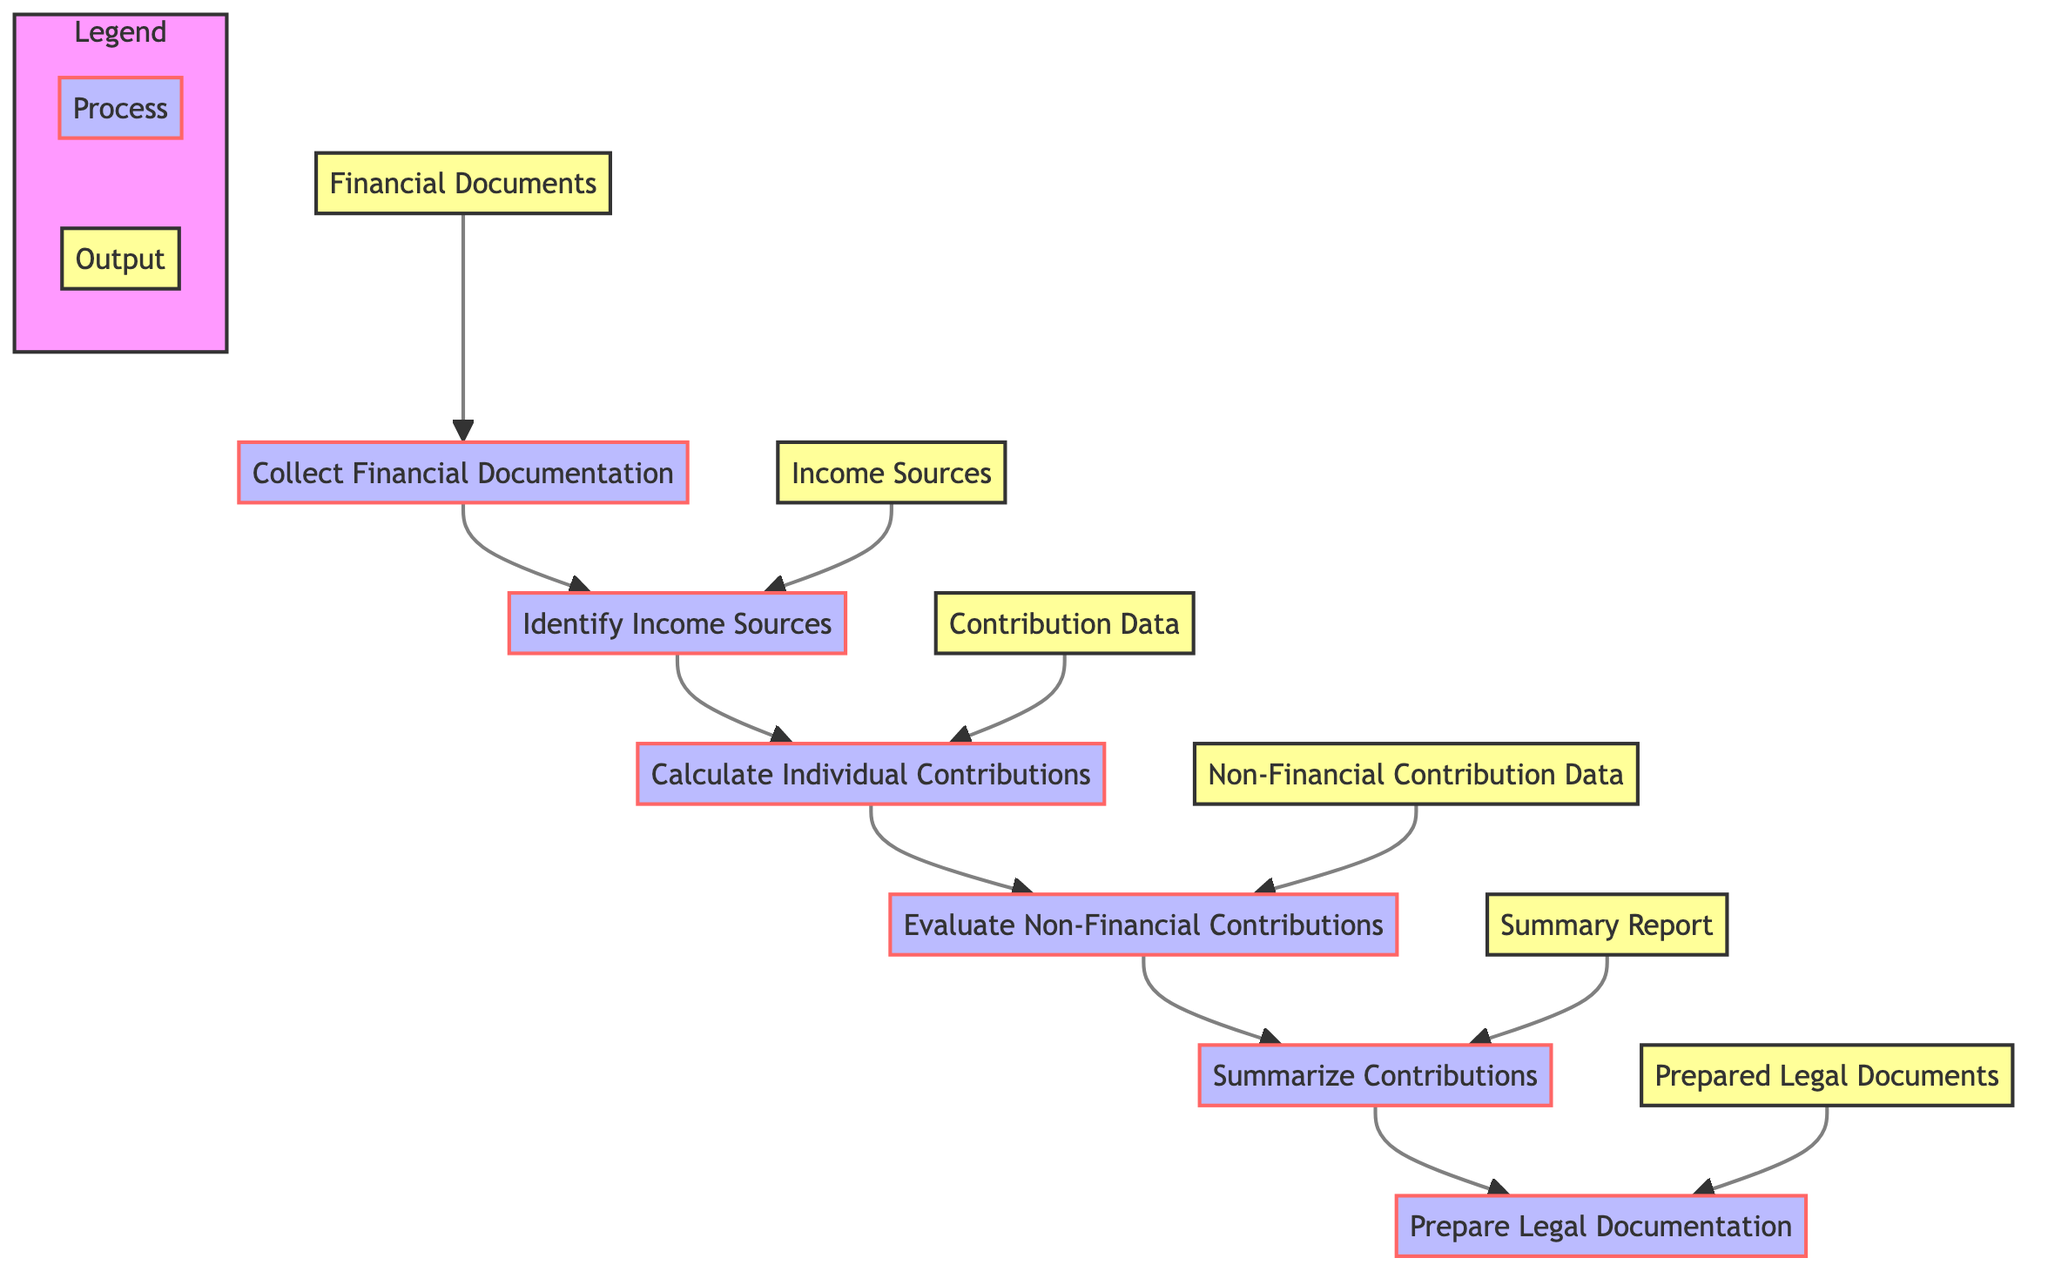What is the first step in the flowchart? The first step in the flowchart is "Collect Financial Documentation," which indicates that gathering relevant financial documents is the starting point of the process.
Answer: Collect Financial Documentation Which step follows "Identify Income Sources"? "Calculate Individual Contributions" directly follows "Identify Income Sources" in the flowchart, indicating that after identifying income sources, the next action is to calculate the contributions.
Answer: Calculate Individual Contributions How many total processes are displayed in the flowchart? The flowchart consists of six processes, which include "Collect Financial Documentation," "Identify Income Sources," "Calculate Individual Contributions," "Evaluate Non-Financial Contributions," "Summarize Contributions," and "Prepare Legal Documentation."
Answer: Six What is the output of the "Summarize Contributions" step? The output of the "Summarize Contributions" step is a "Summary Report," which indicates the result of summarizing both financial and non-financial contributions.
Answer: Summary Report Which node provides input for the "Prepare Legal Documentation" step? The "Summary Report" node provides the necessary input for the "Prepare Legal Documentation" step, showing that the summary needs to be prepared before creating legal documentation.
Answer: Summary Report What determines the flow from "Evaluate Non-Financial Contributions" to "Summarize Contributions"? The flow is determined by the completion of evaluating non-financial contributions, which is a prerequisite to summarizing all contributions, indicating a logical sequence in the process.
Answer: Evaluated contributions What types of contributions are assessed in the "Evaluate Non-Financial Contributions" step? The contributions assessed in this step include "Homemaking Activities," "Childcare Responsibilities," and "Career Sacrifices," which are all non-financial in nature.
Answer: Homemaking Activities, Childcare Responsibilities, Career Sacrifices Which step produces output documentation that is critical for divorce proceedings? "Prepare Legal Documentation" is the step that produces legal documentation critical for divorce proceedings, emphasizing its importance in the legal context.
Answer: Prepared Legal Documents What is the last process in the flowchart? The last process in the flowchart is "Prepare Legal Documentation," which indicates it is the final action taken after all evaluations and calculations are complete.
Answer: Prepare Legal Documentation 